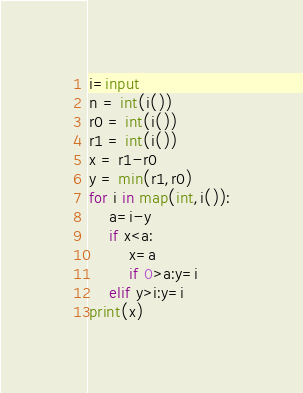Convert code to text. <code><loc_0><loc_0><loc_500><loc_500><_Python_>i=input
n = int(i())
r0 = int(i())
r1 = int(i())
x = r1-r0
y = min(r1,r0)
for i in map(int,i()):
    a=i-y
    if x<a:
        x=a
        if 0>a:y=i
    elif y>i:y=i
print(x)</code> 